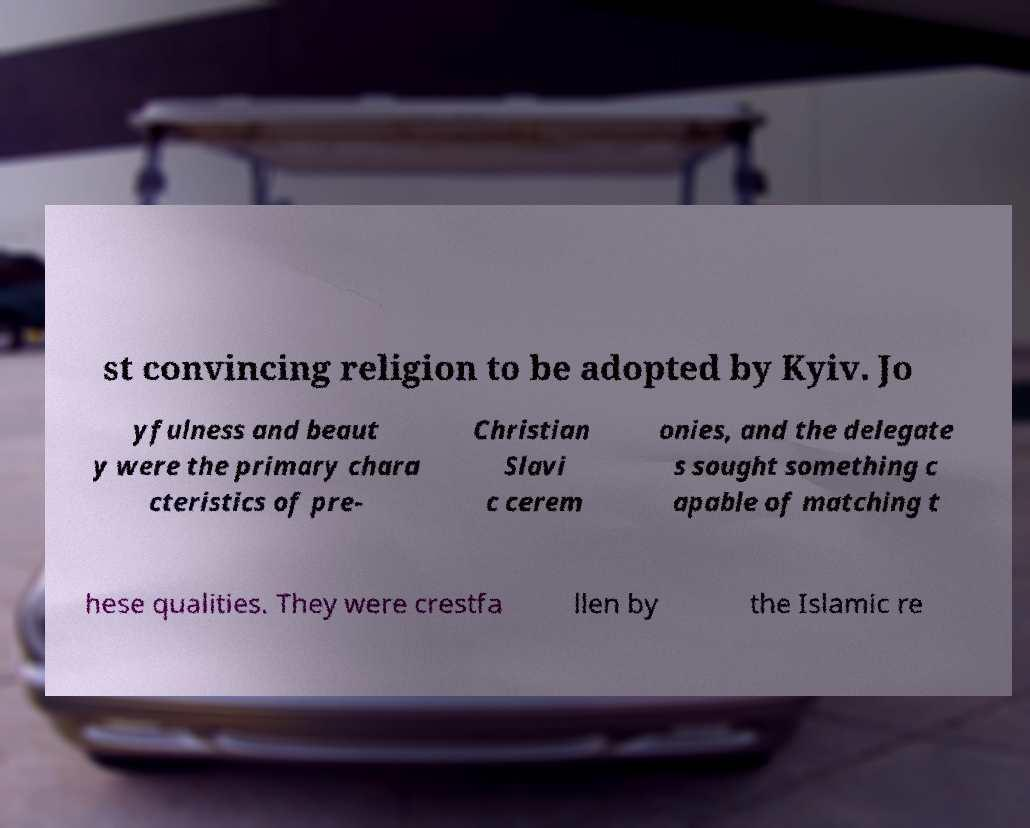Please read and relay the text visible in this image. What does it say? st convincing religion to be adopted by Kyiv. Jo yfulness and beaut y were the primary chara cteristics of pre- Christian Slavi c cerem onies, and the delegate s sought something c apable of matching t hese qualities. They were crestfa llen by the Islamic re 